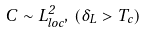<formula> <loc_0><loc_0><loc_500><loc_500>C \sim L _ { l o c } ^ { 2 } , \, ( \delta _ { L } > T _ { c } )</formula> 